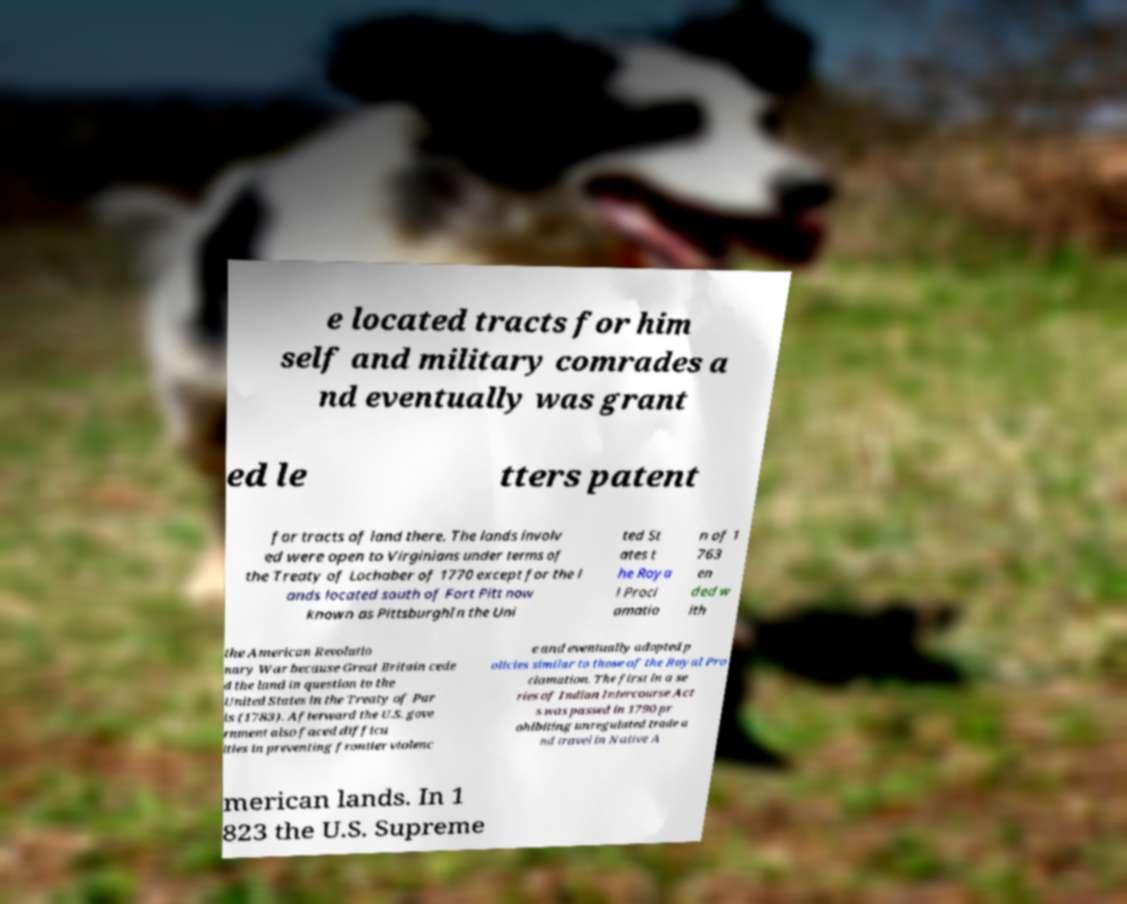Could you extract and type out the text from this image? e located tracts for him self and military comrades a nd eventually was grant ed le tters patent for tracts of land there. The lands involv ed were open to Virginians under terms of the Treaty of Lochaber of 1770 except for the l ands located south of Fort Pitt now known as PittsburghIn the Uni ted St ates t he Roya l Procl amatio n of 1 763 en ded w ith the American Revolutio nary War because Great Britain cede d the land in question to the United States in the Treaty of Par is (1783). Afterward the U.S. gove rnment also faced difficu lties in preventing frontier violenc e and eventually adopted p olicies similar to those of the Royal Pro clamation. The first in a se ries of Indian Intercourse Act s was passed in 1790 pr ohibiting unregulated trade a nd travel in Native A merican lands. In 1 823 the U.S. Supreme 